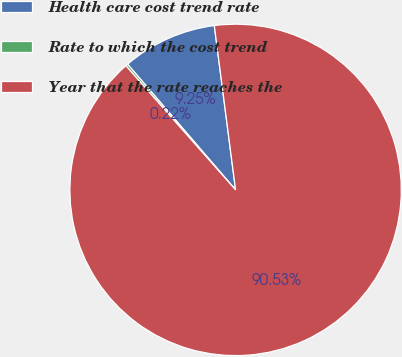Convert chart. <chart><loc_0><loc_0><loc_500><loc_500><pie_chart><fcel>Health care cost trend rate<fcel>Rate to which the cost trend<fcel>Year that the rate reaches the<nl><fcel>9.25%<fcel>0.22%<fcel>90.52%<nl></chart> 